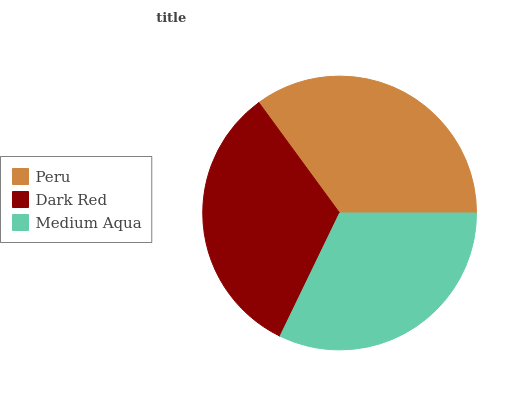Is Medium Aqua the minimum?
Answer yes or no. Yes. Is Peru the maximum?
Answer yes or no. Yes. Is Dark Red the minimum?
Answer yes or no. No. Is Dark Red the maximum?
Answer yes or no. No. Is Peru greater than Dark Red?
Answer yes or no. Yes. Is Dark Red less than Peru?
Answer yes or no. Yes. Is Dark Red greater than Peru?
Answer yes or no. No. Is Peru less than Dark Red?
Answer yes or no. No. Is Dark Red the high median?
Answer yes or no. Yes. Is Dark Red the low median?
Answer yes or no. Yes. Is Peru the high median?
Answer yes or no. No. Is Medium Aqua the low median?
Answer yes or no. No. 